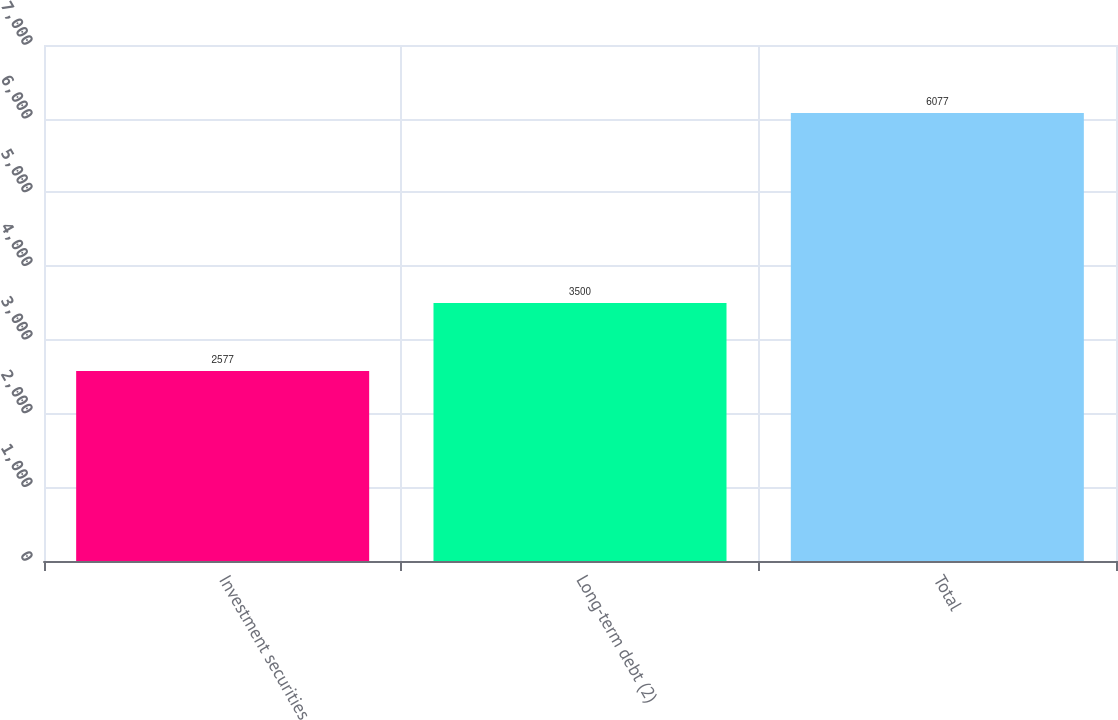Convert chart. <chart><loc_0><loc_0><loc_500><loc_500><bar_chart><fcel>Investment securities<fcel>Long-term debt (2)<fcel>Total<nl><fcel>2577<fcel>3500<fcel>6077<nl></chart> 